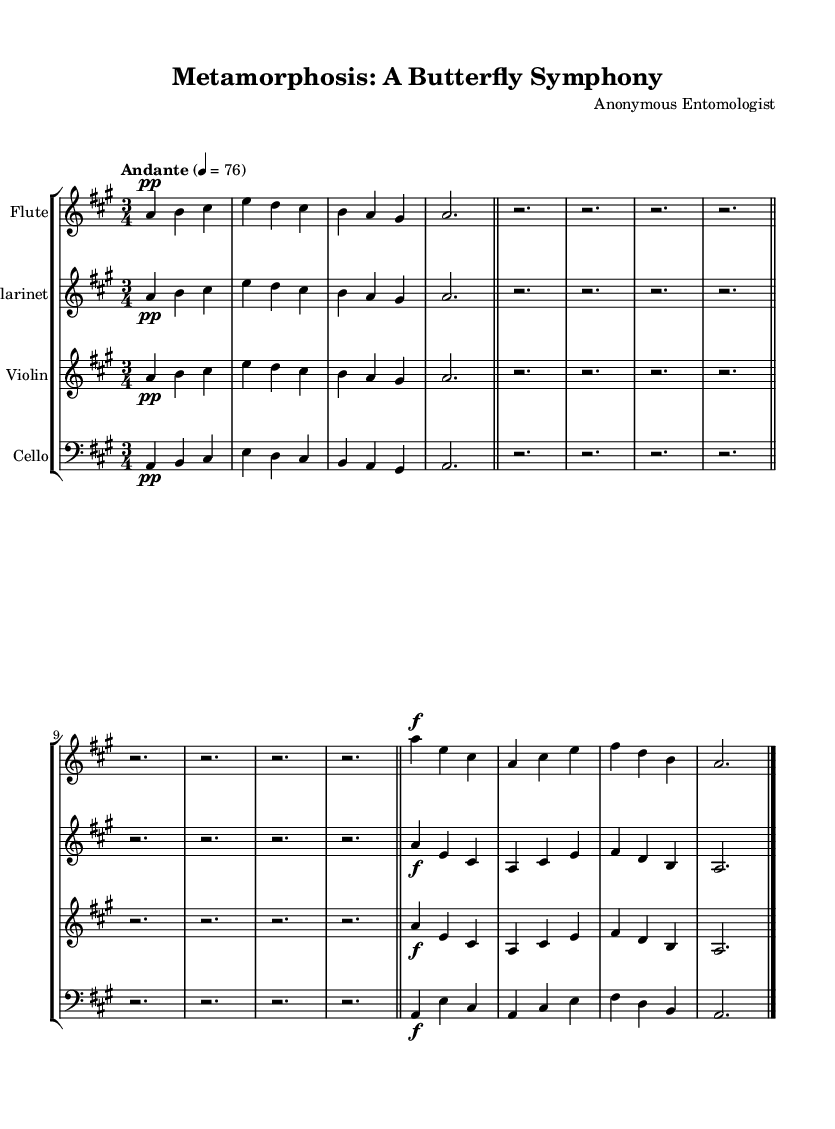What is the key signature of this music? The key signature displayed in the music indicates a major scale with three sharps, which point to A major.
Answer: A major What is the time signature of this piece? The time signature written in the music shows that there are three beats in each measure, indicated by the 3/4 time signature.
Answer: 3/4 What is the tempo marking for this symphony? The tempo marking states "Andante," along with a metronome marking of 4 = 76, which indicates a moderate walking pace.
Answer: Andante How many measures are in the flute section? Counting the bars in the flute section, there are a total of six measures displayed, each separated by bar lines.
Answer: 6 What dynamics are indicated for the first segment of the cello music? The cello music begins with a soft dynamic marking of "pp," signifying that it should be played pianissimo or very softly.
Answer: pp What musical technique is used at the end of each section? At the end of each section, a rest is used to signify a pause in the music, indicated by whole rests spanning the measures.
Answer: Rest Which instruments are represented in the score? The score includes parts for four instruments: Flute, Clarinet, Violin, and Cello, as labeled at the beginning of each staff.
Answer: Flute, Clarinet, Violin, Cello 